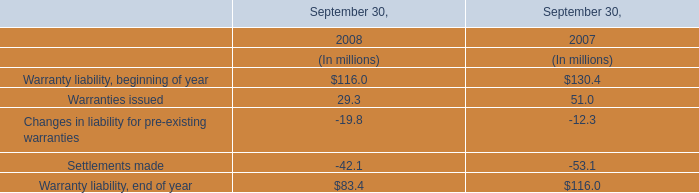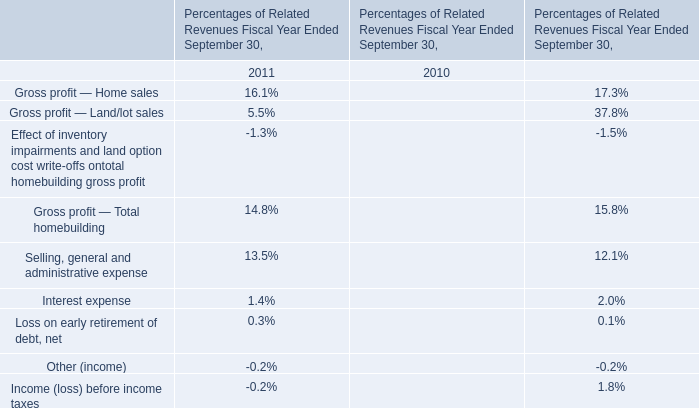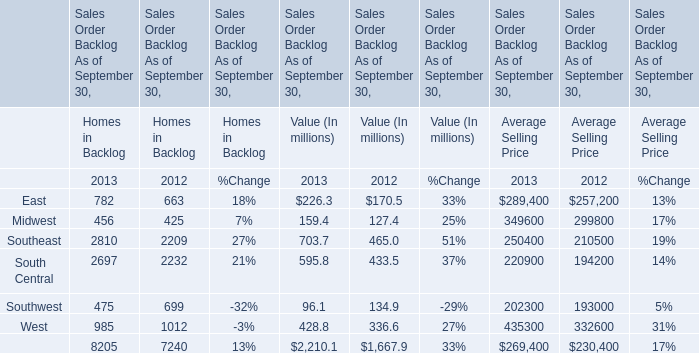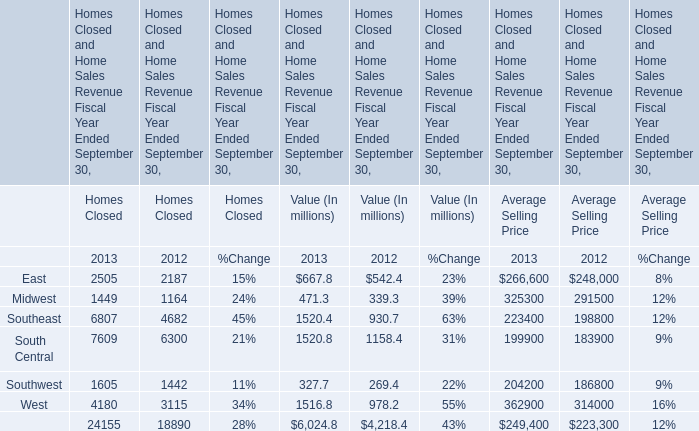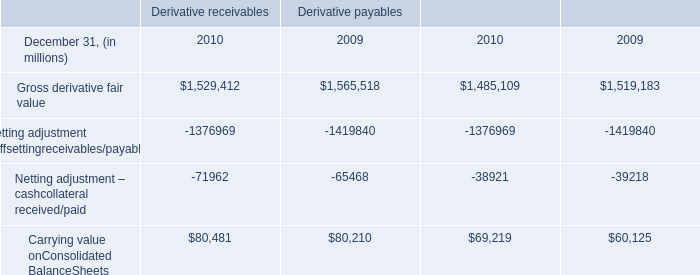What do all Homes Closed sum up without those East smaller than 3000, in 2013? (in million) 
Computations: (24155 - 2505)
Answer: 21650.0. 